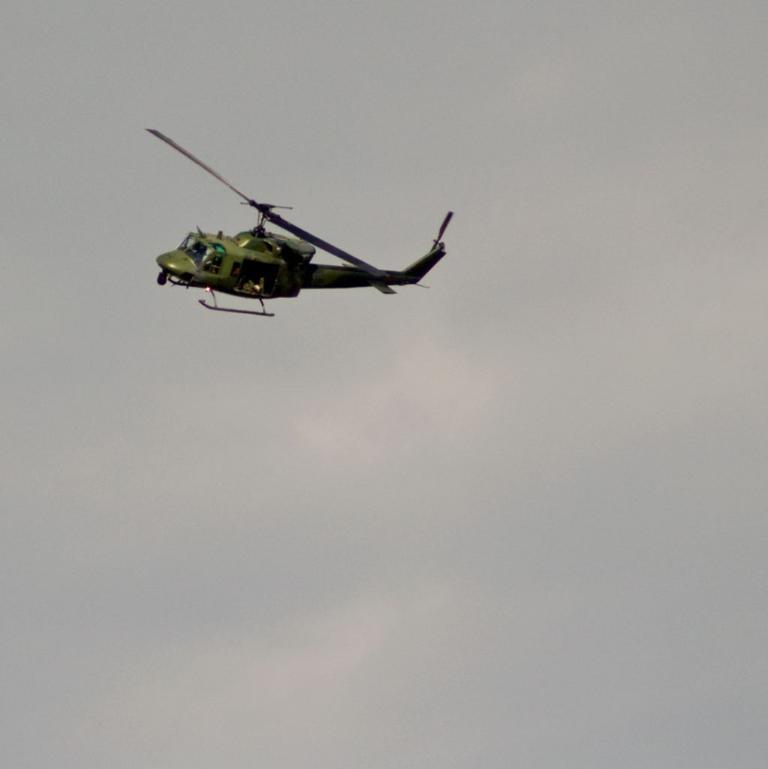What is the main subject of the picture? The main subject of the picture is a helicopter. What feature is present on the helicopter? The helicopter has a fan. What color is the helicopter? The helicopter is green in color. What can be seen in the background of the image? There is a sky visible in the background of the image. What is the condition of the sky in the picture? Clouds are present in the sky. What type of agreement was signed in the image? There is no agreement or signing event depicted in the image; it features a green helicopter with a fan. What historical event is being commemorated in the image? There is no historical event being commemorated in the image; it features a green helicopter with a fan. 